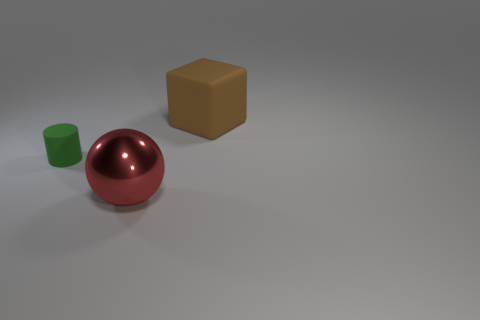Is there anything else that is the same size as the rubber cylinder?
Keep it short and to the point. No. The thing to the left of the red metallic sphere has what shape?
Keep it short and to the point. Cylinder. There is a red ball; does it have the same size as the matte thing that is to the right of the tiny green thing?
Make the answer very short. Yes. Is there a cylinder made of the same material as the big brown cube?
Your answer should be compact. Yes. How many cylinders are either tiny green things or big matte objects?
Keep it short and to the point. 1. There is a matte thing right of the large red metallic thing; are there any shiny things that are to the right of it?
Your response must be concise. No. Are there fewer red balls than small blocks?
Make the answer very short. No. What number of other matte things have the same shape as the big matte object?
Keep it short and to the point. 0. What number of blue things are either large spheres or metallic cylinders?
Keep it short and to the point. 0. What is the size of the matte object that is on the left side of the object in front of the cylinder?
Give a very brief answer. Small. 